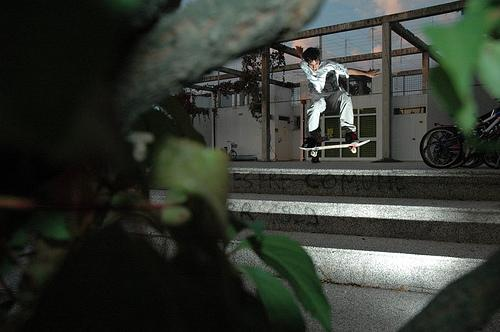Provide a brief description of the primary action happening in this image. A boy is skateboarding, performing a trick on grey stairs with graffiti on them. Describe the setting of the image involving the boy skateboarding. The setting is an outdoor urban area with grey stairs, graffiti, hanging plants, metal fencing, and bikes parked nearby. Answer a multiple choice question: What's the color of the boy's shirt? The color of the boy's shirt is white. What apparel is the boy in the image wearing? The boy is wearing a white shirt, white pants, and black shoes. Mention a detail about the skateboard in the image. The skateboard has red and white wheels. For a product advertisement, describe the scene featuring the skateboarder performing a trick. Capture the excitement of skateboarding with our durable and stylish board, as this talented boy expertly performs a trick on grey stairs, surrounded by lively city environment and colorful graffiti. Explain a visual entailment in the image about the boy's clothing and the environment. The light shining on the boy's white clothes suggests that it's a sunny day in the outdoor environment. Pick a task: Describe the environment where the picture was taken. The picture was taken outside, with plants hanging from the ceiling, a large green plant, metal fencing behind the boy, and bikes parked near the steps. Indicate a referential expression grounding of the boy's appearance. The boy has dark hair, is wearing a white shirt and white pants, and has his arms extended. What is a notable aspect in the background of the image, relating to transportation? A motorcycle is parked near the boy skating on the stairs. 